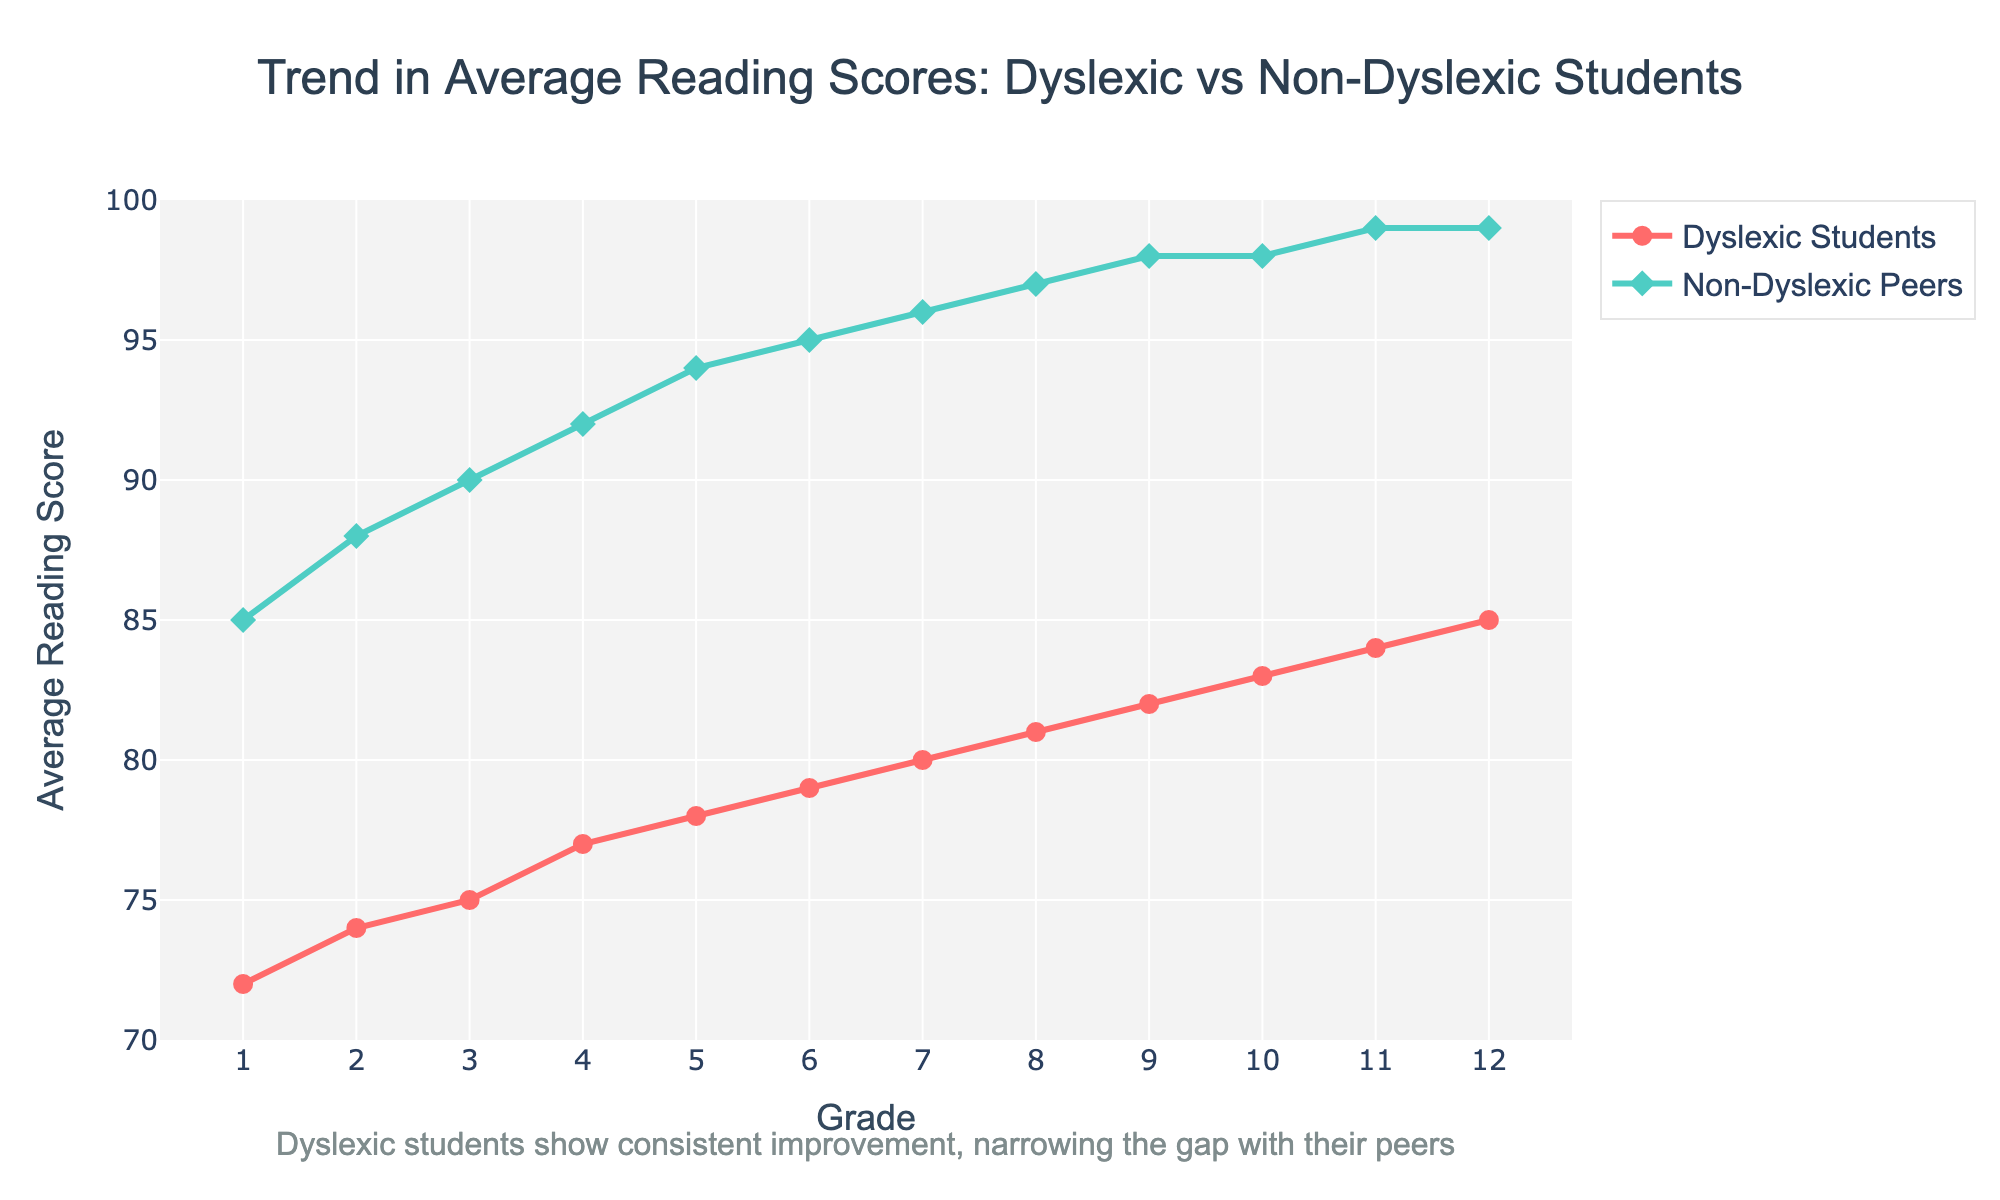What grade do dyslexic students reach the same average reading score as non-dyslexic students in grade 1? Dyslexic students reach an average reading score of 85 in grade 12, which matches the non-dyslexic students' average reading score in grade 1.
Answer: Grade 12 At which grade level is the gap between dyslexic and non-dyslexic students' average reading scores the smallest? The gap is the smallest when the lines representing dyslexic and non-dyslexic students are closest together. In grade 12, the non-dyslexic score is 99, and the dyslexic score is 85, with a gap of 14 being the smallest observed.
Answer: Grade 12 Between which two consecutive grades is the improvement in reading scores the largest for dyslexic students? To find this, check the difference in scores between consecutive grades: Grade 2 to Grade 3 shows the largest increase. The difference is 74 to 75, an increase of 1.
Answer: Grade 2 to 3 How much does the average reading score improve from grade 6 to grade 12 for dyslexic students? The average reading score in Grade 6 for dyslexic students is 79, and in Grade 12, it is 85. The improvement is calculated as 85 - 79 = 6.
Answer: 6 In which grade do non-dyslexic students first achieve an average reading score of 95? Non-dyslexic students first achieve an average score of 95 in grade 6, as noted by their reading scores data.
Answer: Grade 6 What is the difference in average reading scores between grades 1 and 12 for non-dyslexic peers? The scores for non-dyslexic students in Grade 1 is 85 and in Grade 12 is 99; the difference is 99 - 85 = 14.
Answer: 14 Which student group shows more consistent progress in reading scores across grades? Dyslexic students show consistent progress because their line has steady upward sloping with no plateaus or declines.
Answer: Dyslexic Students What color represents the trends of dyslexic students in the chart? Dyslexic students are represented by the red line in the chart.
Answer: Red How much is the improvement in average reading scores for non-dyslexic students from grade 1 to grade 5? Non-dyslexic students improve from an average score of 85 in grade 1 to 94 in grade 5, so the improvement is 94 - 85 = 9.
Answer: 9 What is the average reading score of dyslexic students in grade 10 and 12 combined? Combine the scores of dyslexic students in grades 10 and 12, which are 83 and 85. The mean is calculated as (83 + 85) / 2 = 84.
Answer: 84 